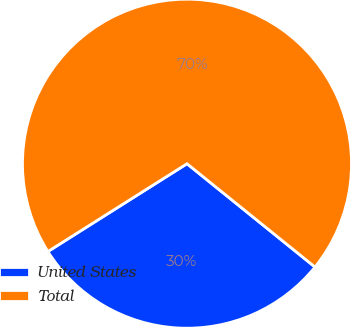<chart> <loc_0><loc_0><loc_500><loc_500><pie_chart><fcel>United States<fcel>Total<nl><fcel>30.23%<fcel>69.77%<nl></chart> 